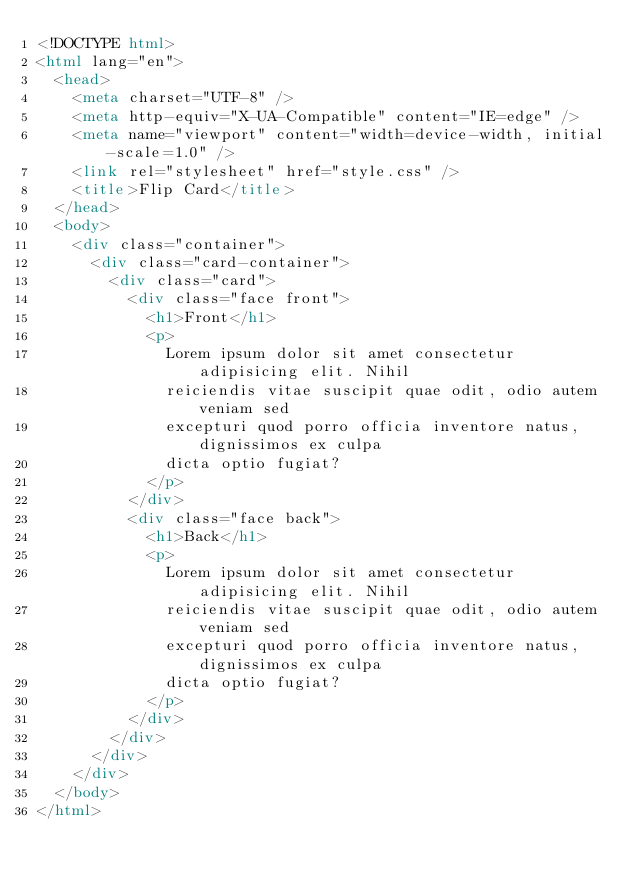<code> <loc_0><loc_0><loc_500><loc_500><_HTML_><!DOCTYPE html>
<html lang="en">
  <head>
    <meta charset="UTF-8" />
    <meta http-equiv="X-UA-Compatible" content="IE=edge" />
    <meta name="viewport" content="width=device-width, initial-scale=1.0" />
    <link rel="stylesheet" href="style.css" />
    <title>Flip Card</title>
  </head>
  <body>
    <div class="container">
      <div class="card-container">
        <div class="card">
          <div class="face front">
            <h1>Front</h1>
            <p>
              Lorem ipsum dolor sit amet consectetur adipisicing elit. Nihil
              reiciendis vitae suscipit quae odit, odio autem veniam sed
              excepturi quod porro officia inventore natus, dignissimos ex culpa
              dicta optio fugiat?
            </p>
          </div>
          <div class="face back">
            <h1>Back</h1>
            <p>
              Lorem ipsum dolor sit amet consectetur adipisicing elit. Nihil
              reiciendis vitae suscipit quae odit, odio autem veniam sed
              excepturi quod porro officia inventore natus, dignissimos ex culpa
              dicta optio fugiat?
            </p>
          </div>
        </div>
      </div>
    </div>
  </body>
</html>
</code> 